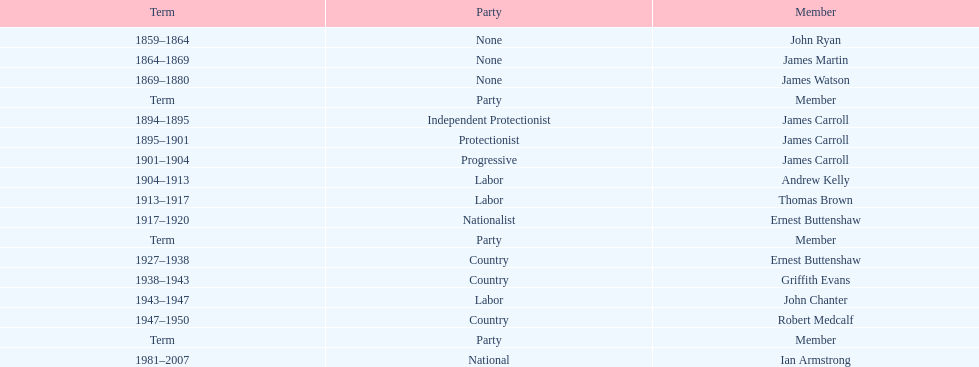How long did the fourth incarnation of the lachlan exist? 1981-2007. 